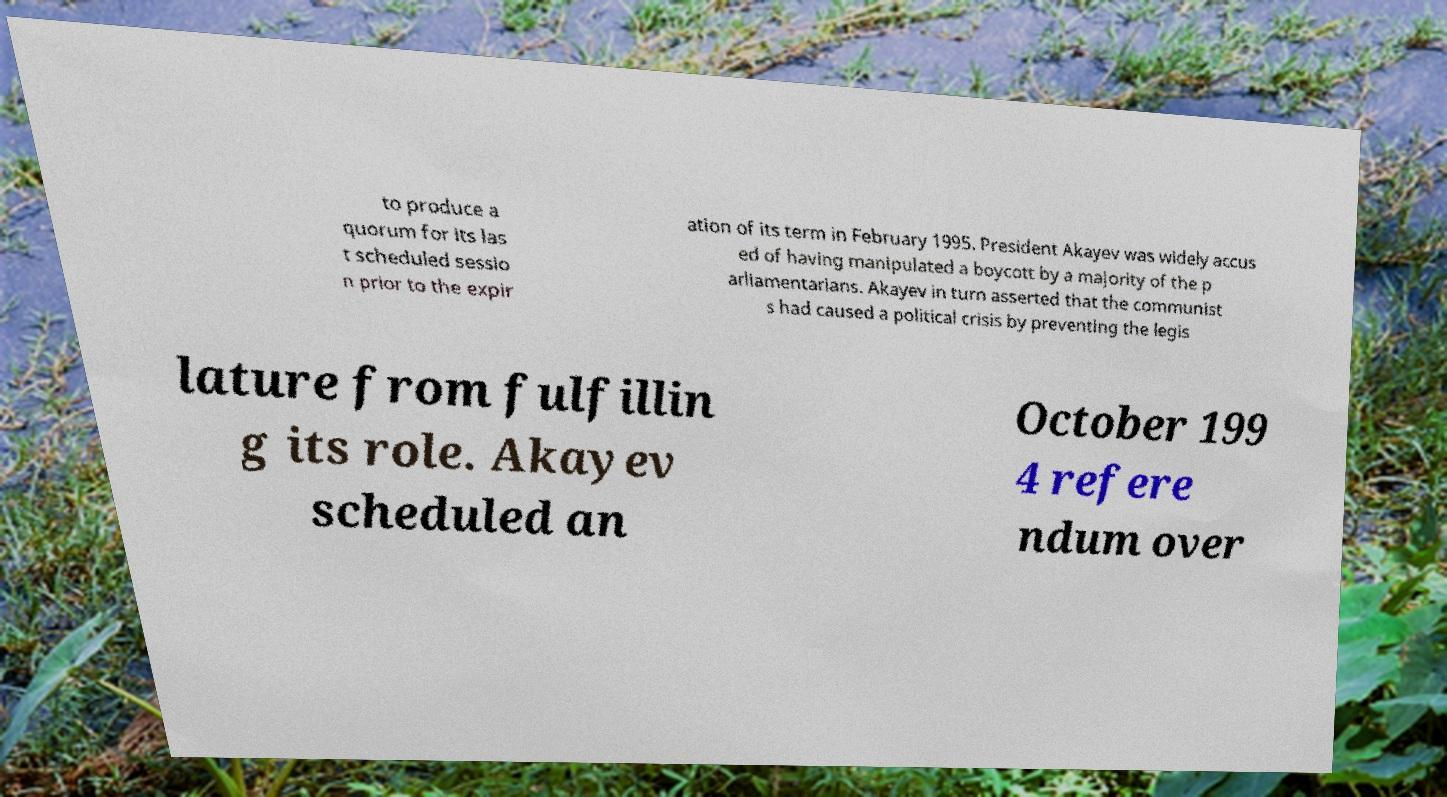Please identify and transcribe the text found in this image. to produce a quorum for its las t scheduled sessio n prior to the expir ation of its term in February 1995. President Akayev was widely accus ed of having manipulated a boycott by a majority of the p arliamentarians. Akayev in turn asserted that the communist s had caused a political crisis by preventing the legis lature from fulfillin g its role. Akayev scheduled an October 199 4 refere ndum over 